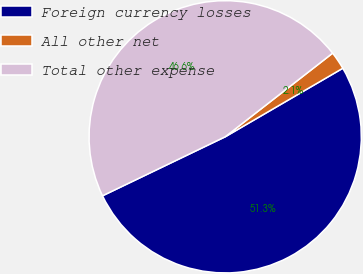Convert chart. <chart><loc_0><loc_0><loc_500><loc_500><pie_chart><fcel>Foreign currency losses<fcel>All other net<fcel>Total other expense<nl><fcel>51.26%<fcel>2.13%<fcel>46.6%<nl></chart> 